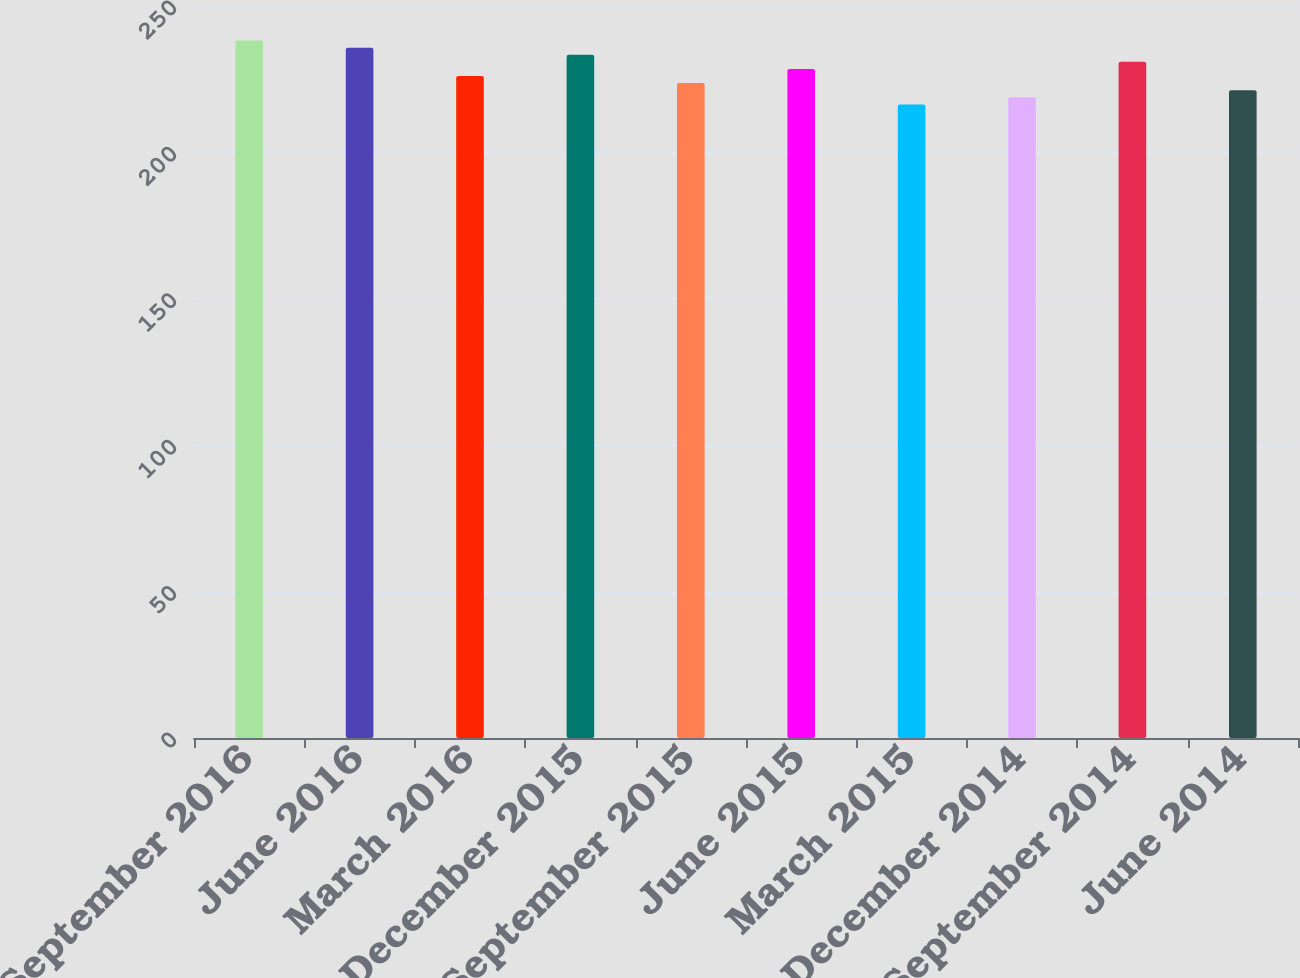Convert chart. <chart><loc_0><loc_0><loc_500><loc_500><bar_chart><fcel>September 2016<fcel>June 2016<fcel>March 2016<fcel>December 2015<fcel>September 2015<fcel>June 2015<fcel>March 2015<fcel>December 2014<fcel>September 2014<fcel>June 2014<nl><fcel>238.18<fcel>235.76<fcel>226.08<fcel>233.34<fcel>223.66<fcel>228.5<fcel>216.4<fcel>218.82<fcel>230.92<fcel>221.24<nl></chart> 